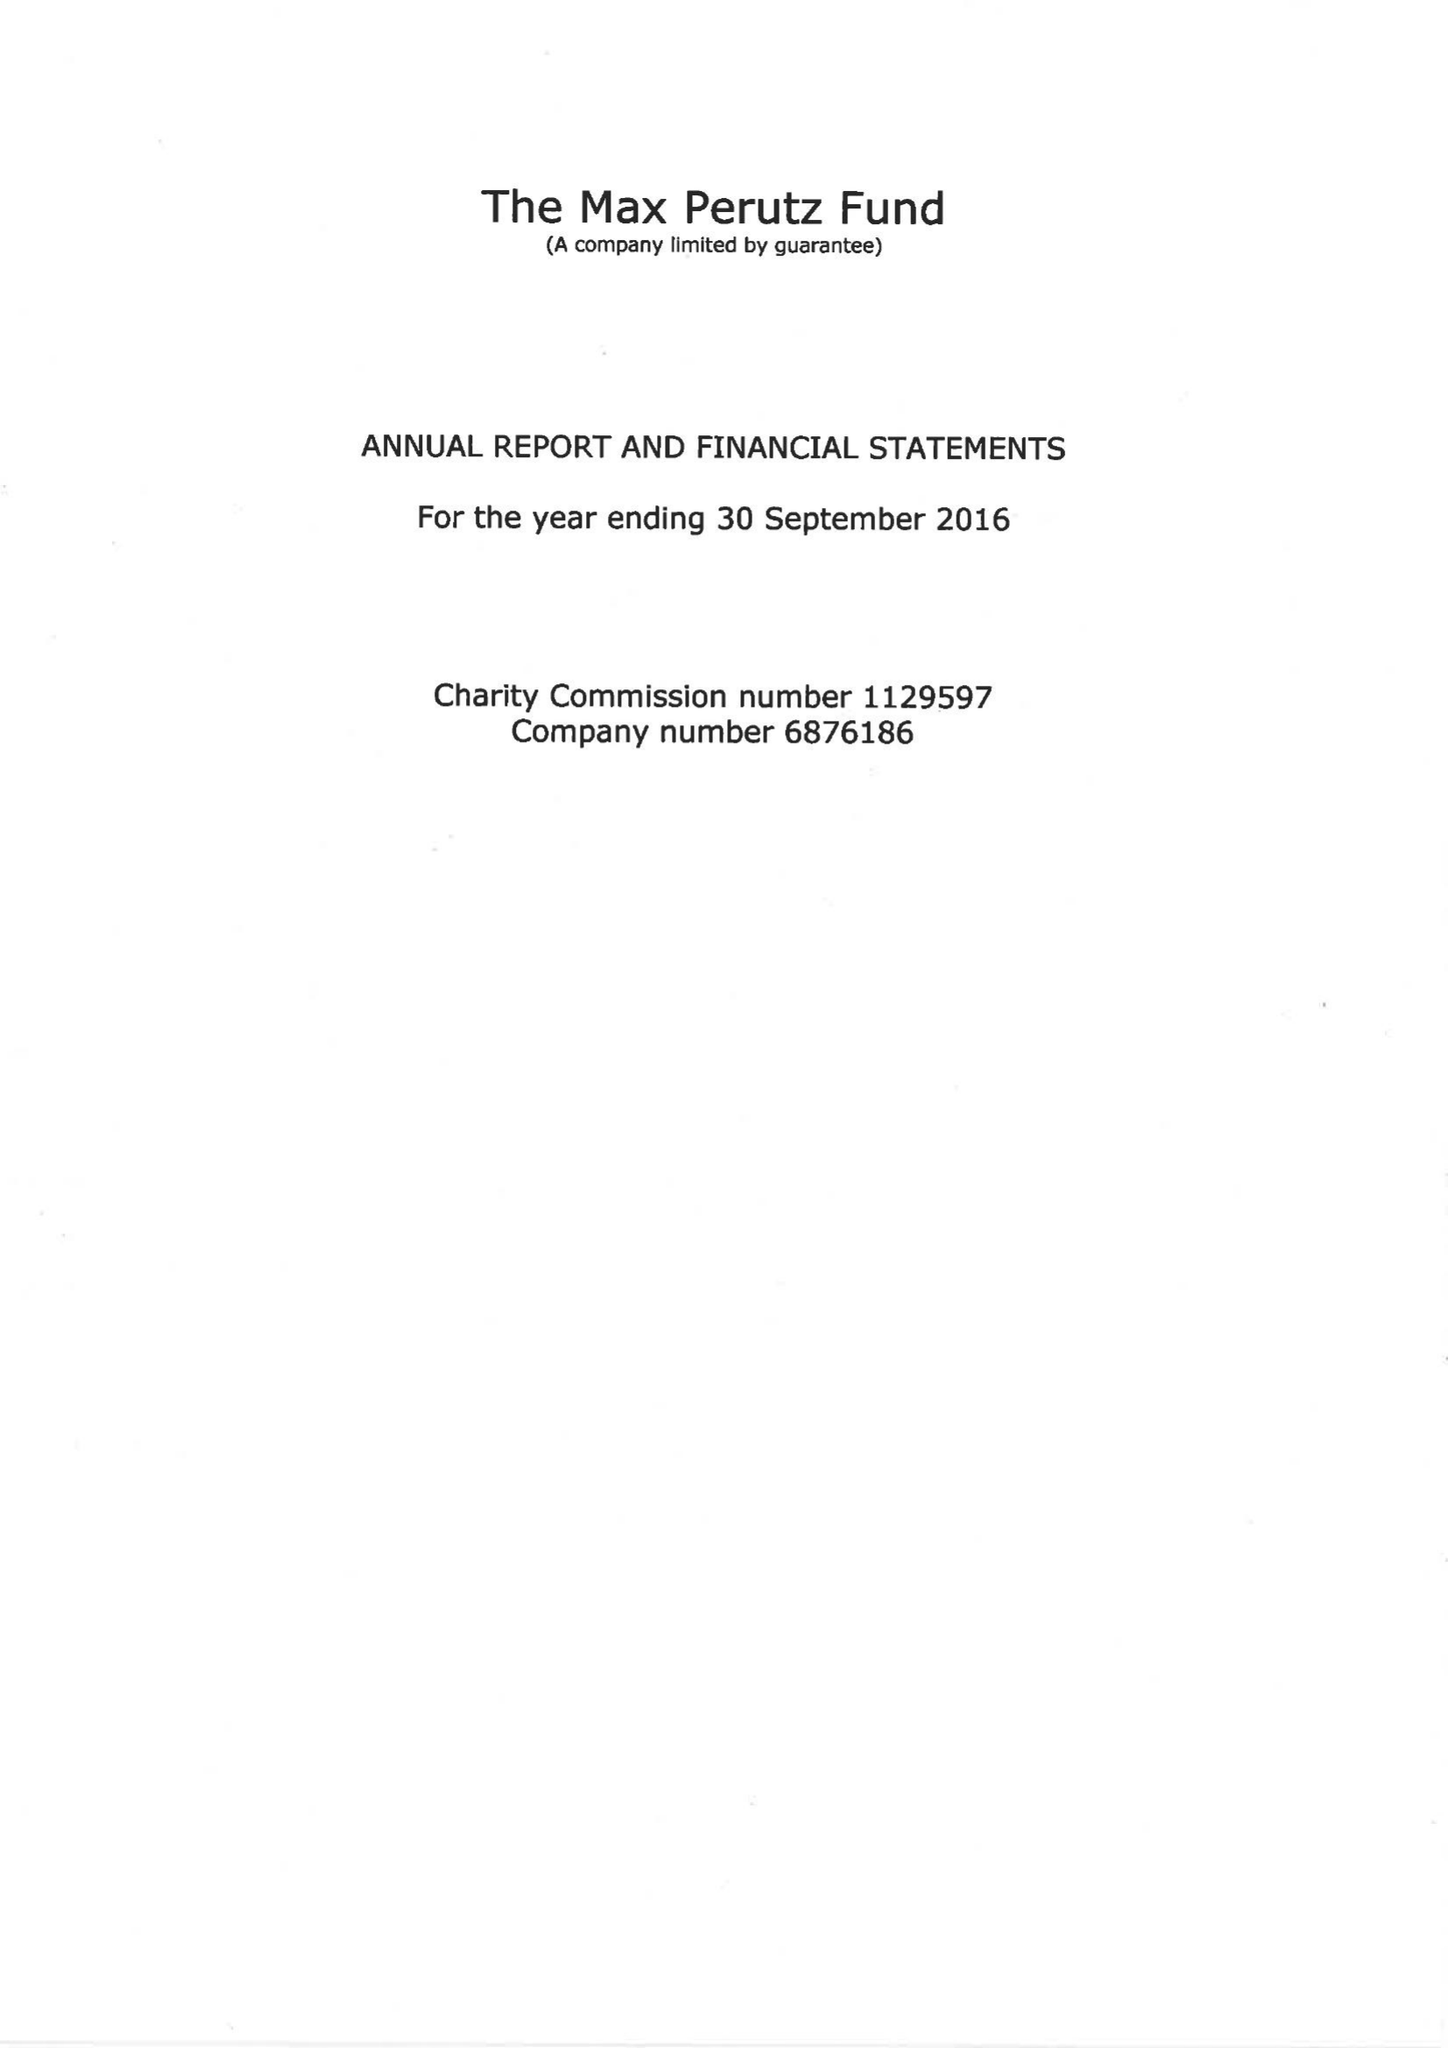What is the value for the address__postcode?
Answer the question using a single word or phrase. CB2 0QH 